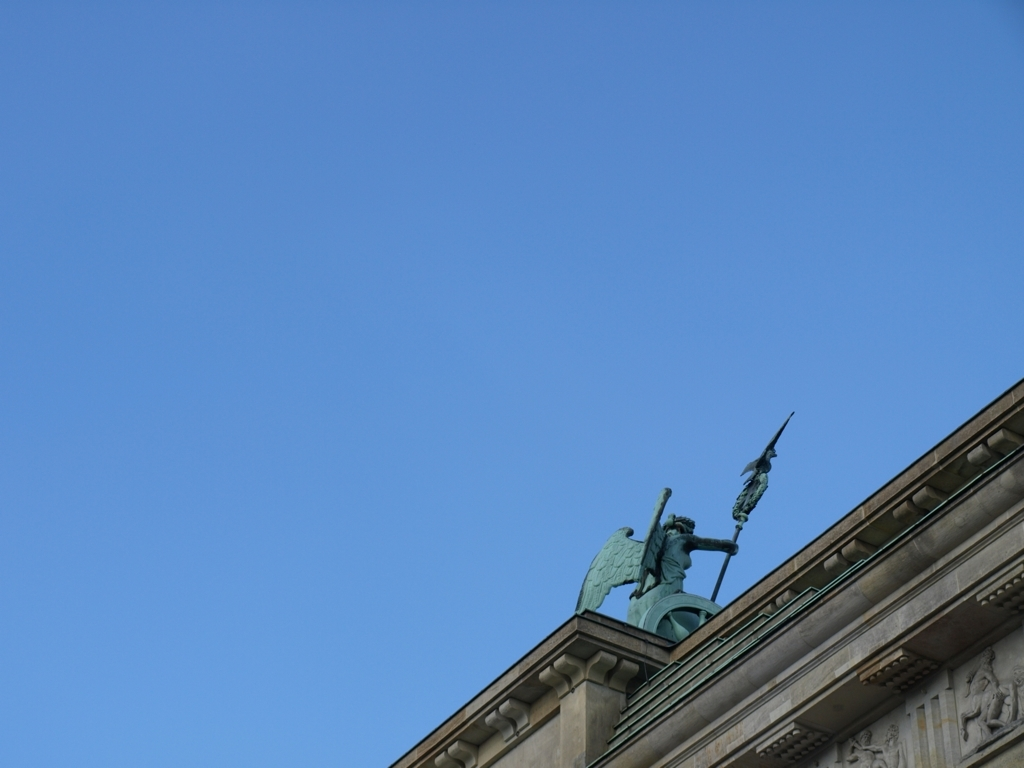Can you provide some techniques on how to improve the photography of static objects like sculptures? Certainly! When photographing sculptures, consider various angles to capture different perspectives. Play with the lighting to highlight textures and details. If possible, use a lower aperture for a shallow depth of field to make the sculpture stand out from the background. Experiment with the time of day for different natural lighting effects. 